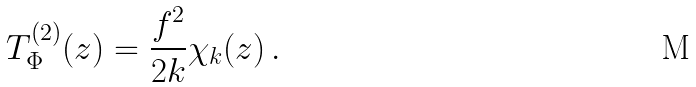Convert formula to latex. <formula><loc_0><loc_0><loc_500><loc_500>T _ { \Phi } ^ { ( 2 ) } ( z ) = \frac { f ^ { 2 } } { 2 k } \chi _ { k } ( z ) \, .</formula> 